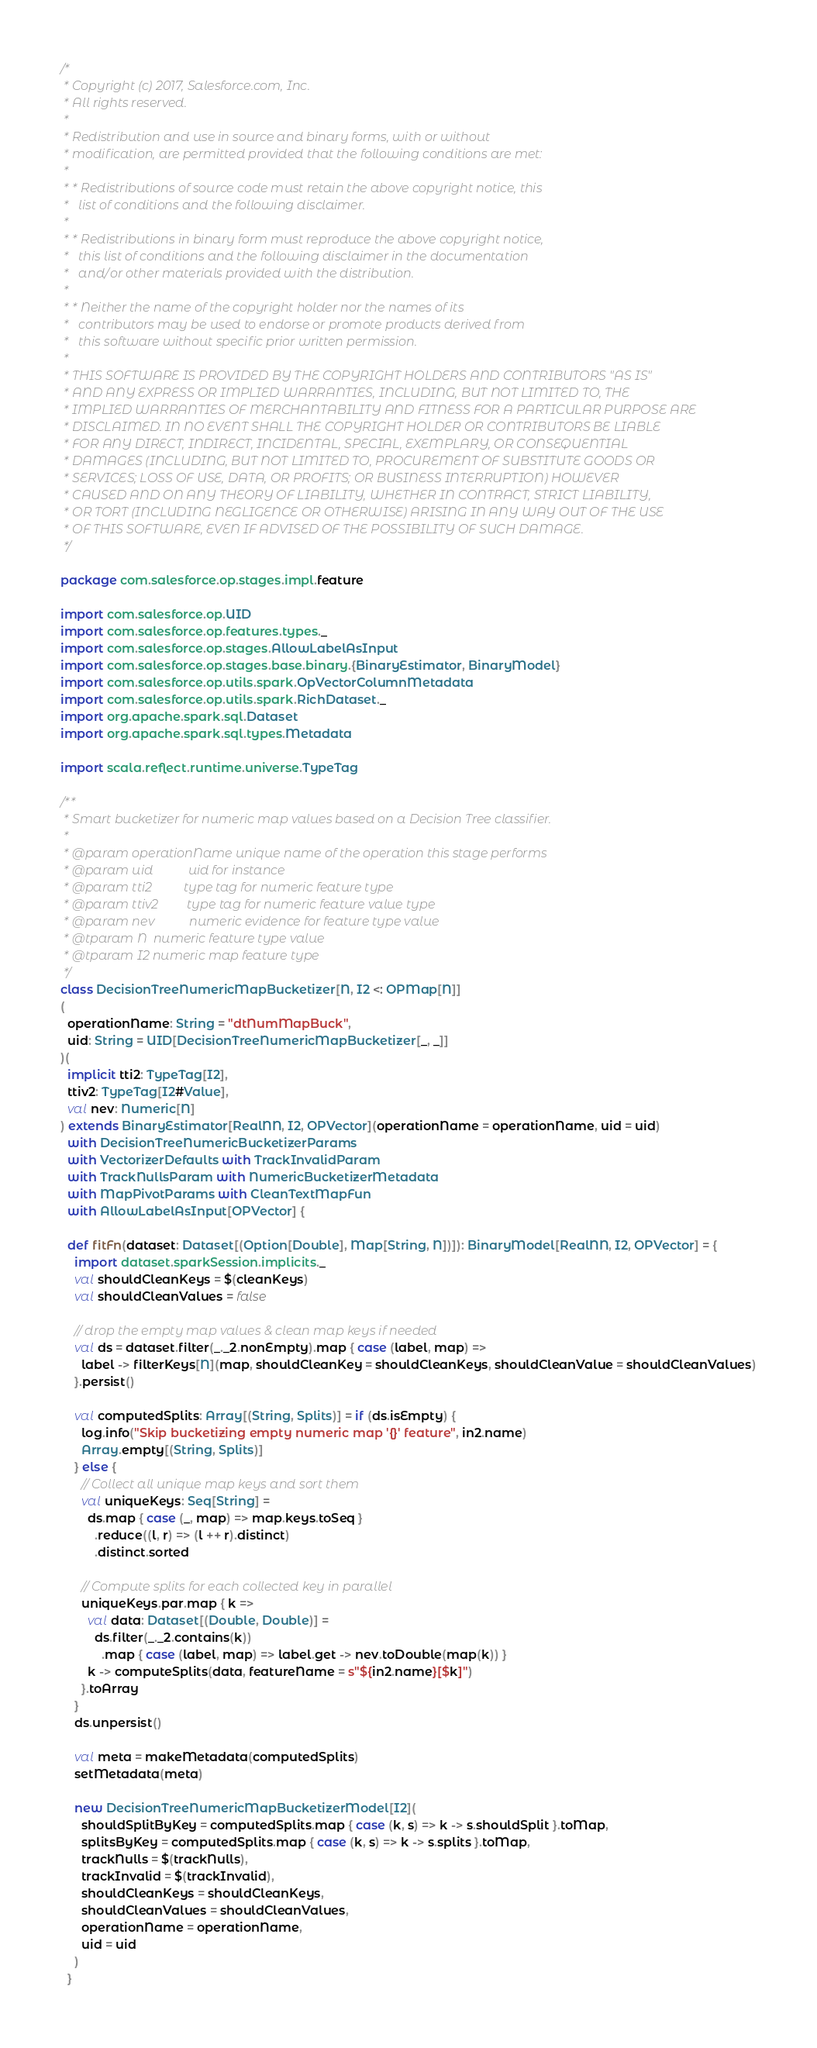<code> <loc_0><loc_0><loc_500><loc_500><_Scala_>/*
 * Copyright (c) 2017, Salesforce.com, Inc.
 * All rights reserved.
 *
 * Redistribution and use in source and binary forms, with or without
 * modification, are permitted provided that the following conditions are met:
 *
 * * Redistributions of source code must retain the above copyright notice, this
 *   list of conditions and the following disclaimer.
 *
 * * Redistributions in binary form must reproduce the above copyright notice,
 *   this list of conditions and the following disclaimer in the documentation
 *   and/or other materials provided with the distribution.
 *
 * * Neither the name of the copyright holder nor the names of its
 *   contributors may be used to endorse or promote products derived from
 *   this software without specific prior written permission.
 *
 * THIS SOFTWARE IS PROVIDED BY THE COPYRIGHT HOLDERS AND CONTRIBUTORS "AS IS"
 * AND ANY EXPRESS OR IMPLIED WARRANTIES, INCLUDING, BUT NOT LIMITED TO, THE
 * IMPLIED WARRANTIES OF MERCHANTABILITY AND FITNESS FOR A PARTICULAR PURPOSE ARE
 * DISCLAIMED. IN NO EVENT SHALL THE COPYRIGHT HOLDER OR CONTRIBUTORS BE LIABLE
 * FOR ANY DIRECT, INDIRECT, INCIDENTAL, SPECIAL, EXEMPLARY, OR CONSEQUENTIAL
 * DAMAGES (INCLUDING, BUT NOT LIMITED TO, PROCUREMENT OF SUBSTITUTE GOODS OR
 * SERVICES; LOSS OF USE, DATA, OR PROFITS; OR BUSINESS INTERRUPTION) HOWEVER
 * CAUSED AND ON ANY THEORY OF LIABILITY, WHETHER IN CONTRACT, STRICT LIABILITY,
 * OR TORT (INCLUDING NEGLIGENCE OR OTHERWISE) ARISING IN ANY WAY OUT OF THE USE
 * OF THIS SOFTWARE, EVEN IF ADVISED OF THE POSSIBILITY OF SUCH DAMAGE.
 */

package com.salesforce.op.stages.impl.feature

import com.salesforce.op.UID
import com.salesforce.op.features.types._
import com.salesforce.op.stages.AllowLabelAsInput
import com.salesforce.op.stages.base.binary.{BinaryEstimator, BinaryModel}
import com.salesforce.op.utils.spark.OpVectorColumnMetadata
import com.salesforce.op.utils.spark.RichDataset._
import org.apache.spark.sql.Dataset
import org.apache.spark.sql.types.Metadata

import scala.reflect.runtime.universe.TypeTag

/**
 * Smart bucketizer for numeric map values based on a Decision Tree classifier.
 *
 * @param operationName unique name of the operation this stage performs
 * @param uid           uid for instance
 * @param tti2          type tag for numeric feature type
 * @param ttiv2         type tag for numeric feature value type
 * @param nev           numeric evidence for feature type value
 * @tparam N  numeric feature type value
 * @tparam I2 numeric map feature type
 */
class DecisionTreeNumericMapBucketizer[N, I2 <: OPMap[N]]
(
  operationName: String = "dtNumMapBuck",
  uid: String = UID[DecisionTreeNumericMapBucketizer[_, _]]
)(
  implicit tti2: TypeTag[I2],
  ttiv2: TypeTag[I2#Value],
  val nev: Numeric[N]
) extends BinaryEstimator[RealNN, I2, OPVector](operationName = operationName, uid = uid)
  with DecisionTreeNumericBucketizerParams
  with VectorizerDefaults with TrackInvalidParam
  with TrackNullsParam with NumericBucketizerMetadata
  with MapPivotParams with CleanTextMapFun
  with AllowLabelAsInput[OPVector] {

  def fitFn(dataset: Dataset[(Option[Double], Map[String, N])]): BinaryModel[RealNN, I2, OPVector] = {
    import dataset.sparkSession.implicits._
    val shouldCleanKeys = $(cleanKeys)
    val shouldCleanValues = false

    // drop the empty map values & clean map keys if needed
    val ds = dataset.filter(_._2.nonEmpty).map { case (label, map) =>
      label -> filterKeys[N](map, shouldCleanKey = shouldCleanKeys, shouldCleanValue = shouldCleanValues)
    }.persist()

    val computedSplits: Array[(String, Splits)] = if (ds.isEmpty) {
      log.info("Skip bucketizing empty numeric map '{}' feature", in2.name)
      Array.empty[(String, Splits)]
    } else {
      // Collect all unique map keys and sort them
      val uniqueKeys: Seq[String] =
        ds.map { case (_, map) => map.keys.toSeq }
          .reduce((l, r) => (l ++ r).distinct)
          .distinct.sorted

      // Compute splits for each collected key in parallel
      uniqueKeys.par.map { k =>
        val data: Dataset[(Double, Double)] =
          ds.filter(_._2.contains(k))
            .map { case (label, map) => label.get -> nev.toDouble(map(k)) }
        k -> computeSplits(data, featureName = s"${in2.name}[$k]")
      }.toArray
    }
    ds.unpersist()

    val meta = makeMetadata(computedSplits)
    setMetadata(meta)

    new DecisionTreeNumericMapBucketizerModel[I2](
      shouldSplitByKey = computedSplits.map { case (k, s) => k -> s.shouldSplit }.toMap,
      splitsByKey = computedSplits.map { case (k, s) => k -> s.splits }.toMap,
      trackNulls = $(trackNulls),
      trackInvalid = $(trackInvalid),
      shouldCleanKeys = shouldCleanKeys,
      shouldCleanValues = shouldCleanValues,
      operationName = operationName,
      uid = uid
    )
  }
</code> 